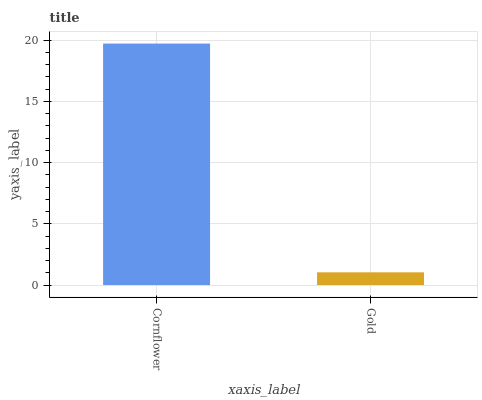Is Gold the minimum?
Answer yes or no. Yes. Is Cornflower the maximum?
Answer yes or no. Yes. Is Gold the maximum?
Answer yes or no. No. Is Cornflower greater than Gold?
Answer yes or no. Yes. Is Gold less than Cornflower?
Answer yes or no. Yes. Is Gold greater than Cornflower?
Answer yes or no. No. Is Cornflower less than Gold?
Answer yes or no. No. Is Cornflower the high median?
Answer yes or no. Yes. Is Gold the low median?
Answer yes or no. Yes. Is Gold the high median?
Answer yes or no. No. Is Cornflower the low median?
Answer yes or no. No. 